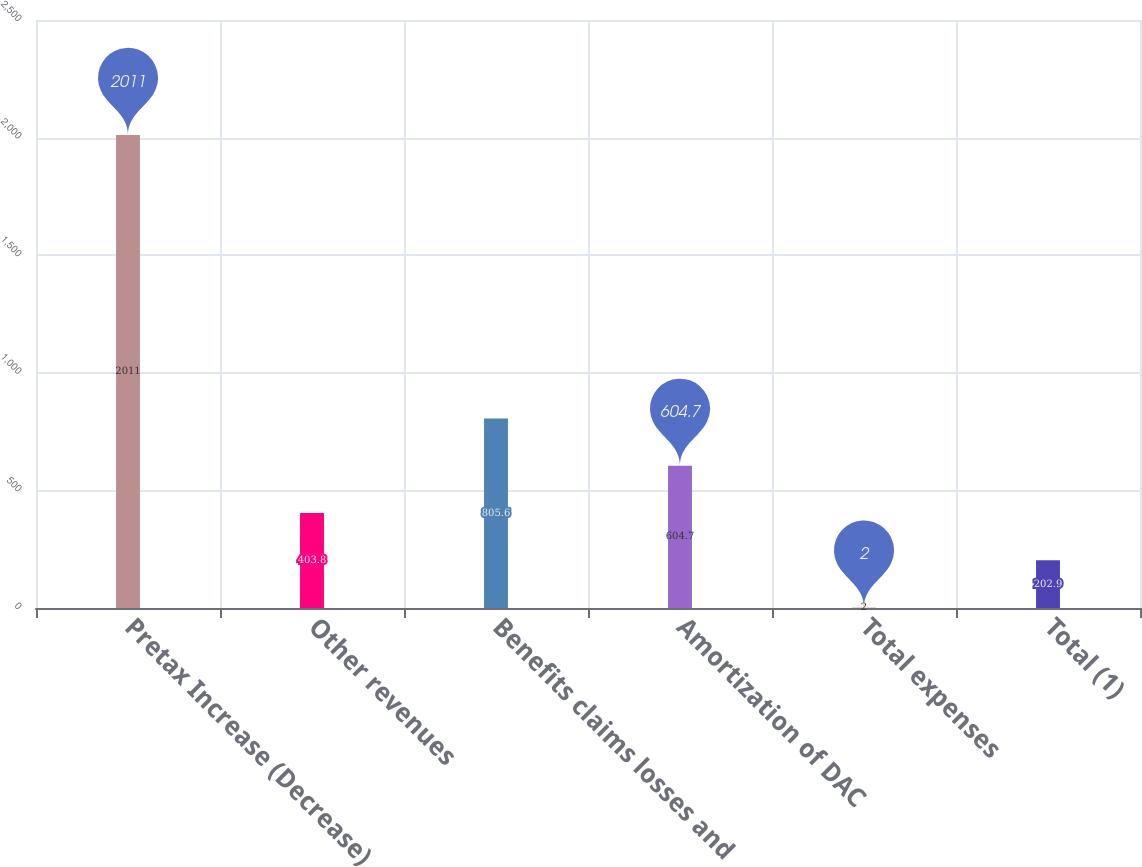Convert chart to OTSL. <chart><loc_0><loc_0><loc_500><loc_500><bar_chart><fcel>Pretax Increase (Decrease)<fcel>Other revenues<fcel>Benefits claims losses and<fcel>Amortization of DAC<fcel>Total expenses<fcel>Total (1)<nl><fcel>2011<fcel>403.8<fcel>805.6<fcel>604.7<fcel>2<fcel>202.9<nl></chart> 